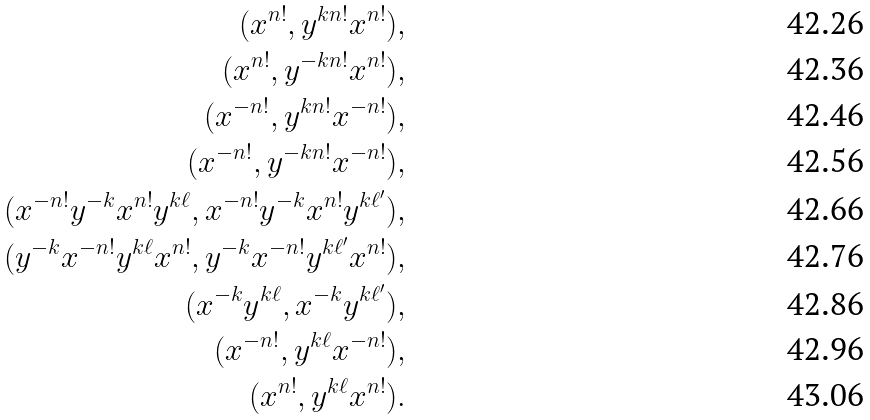<formula> <loc_0><loc_0><loc_500><loc_500>( x ^ { n ! } , y ^ { k n ! } x ^ { n ! } ) , \\ ( x ^ { n ! } , y ^ { - k n ! } x ^ { n ! } ) , \\ ( x ^ { - n ! } , y ^ { k n ! } x ^ { - n ! } ) , \\ ( x ^ { - n ! } , y ^ { - k n ! } x ^ { - n ! } ) , \\ ( x ^ { - n ! } y ^ { - k } x ^ { n ! } y ^ { k \ell } , x ^ { - n ! } y ^ { - k } x ^ { n ! } y ^ { k \ell ^ { \prime } } ) , \\ ( y ^ { - k } x ^ { - n ! } y ^ { k \ell } x ^ { n ! } , y ^ { - k } x ^ { - n ! } y ^ { k \ell ^ { \prime } } x ^ { n ! } ) , \\ ( x ^ { - k } y ^ { k \ell } , x ^ { - k } y ^ { k \ell ^ { \prime } } ) , \\ ( x ^ { - n ! } , y ^ { k \ell } x ^ { - n ! } ) , \\ ( x ^ { n ! } , y ^ { k \ell } x ^ { n ! } ) .</formula> 